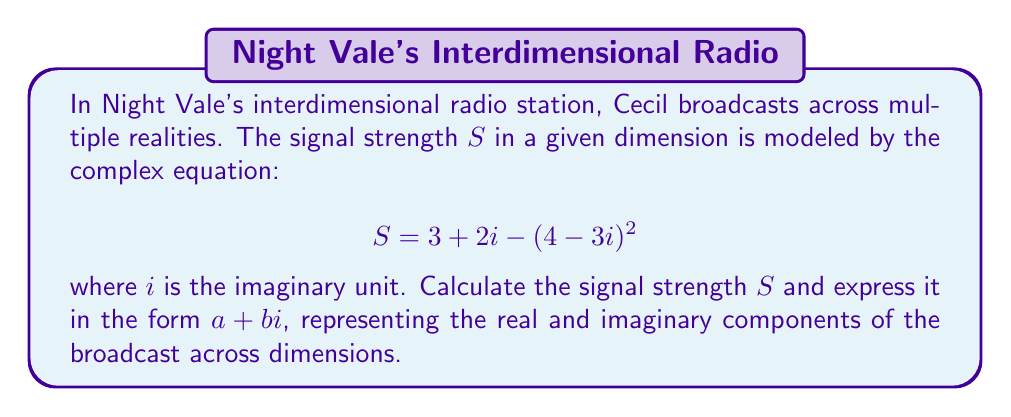Can you answer this question? Let's solve this step-by-step:

1) We start with the equation: $S = 3 + 2i - (4-3i)^2$

2) First, let's focus on simplifying $(4-3i)^2$:
   $$(4-3i)^2 = (4-3i)(4-3i)$$
   
3) Using the FOIL method:
   $$(4-3i)(4-3i) = 16 - 12i - 12i + 9i^2$$
   $$= 16 - 24i + 9i^2$$

4) Recall that $i^2 = -1$:
   $$16 - 24i + 9(-1) = 16 - 24i - 9 = 7 - 24i$$

5) Now our equation looks like:
   $$S = 3 + 2i - (7 - 24i)$$

6) Simplifying:
   $$S = 3 + 2i - 7 + 24i$$
   $$S = -4 + 26i$$

7) This is already in the form $a + bi$, where $a = -4$ and $b = 26$
Answer: $S = -4 + 26i$ 